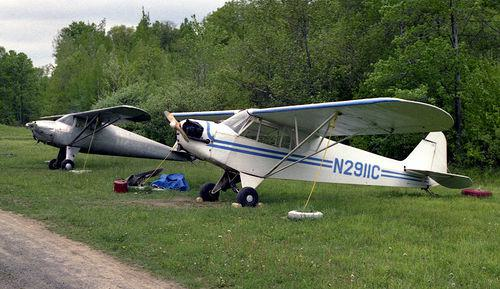What type of landscape surrounds the aeroplanes in this image? The aeroplanes are surrounded by a lush, green landscape that appears to be a grassy field, which is typically indicative of a rural or countryside area. 